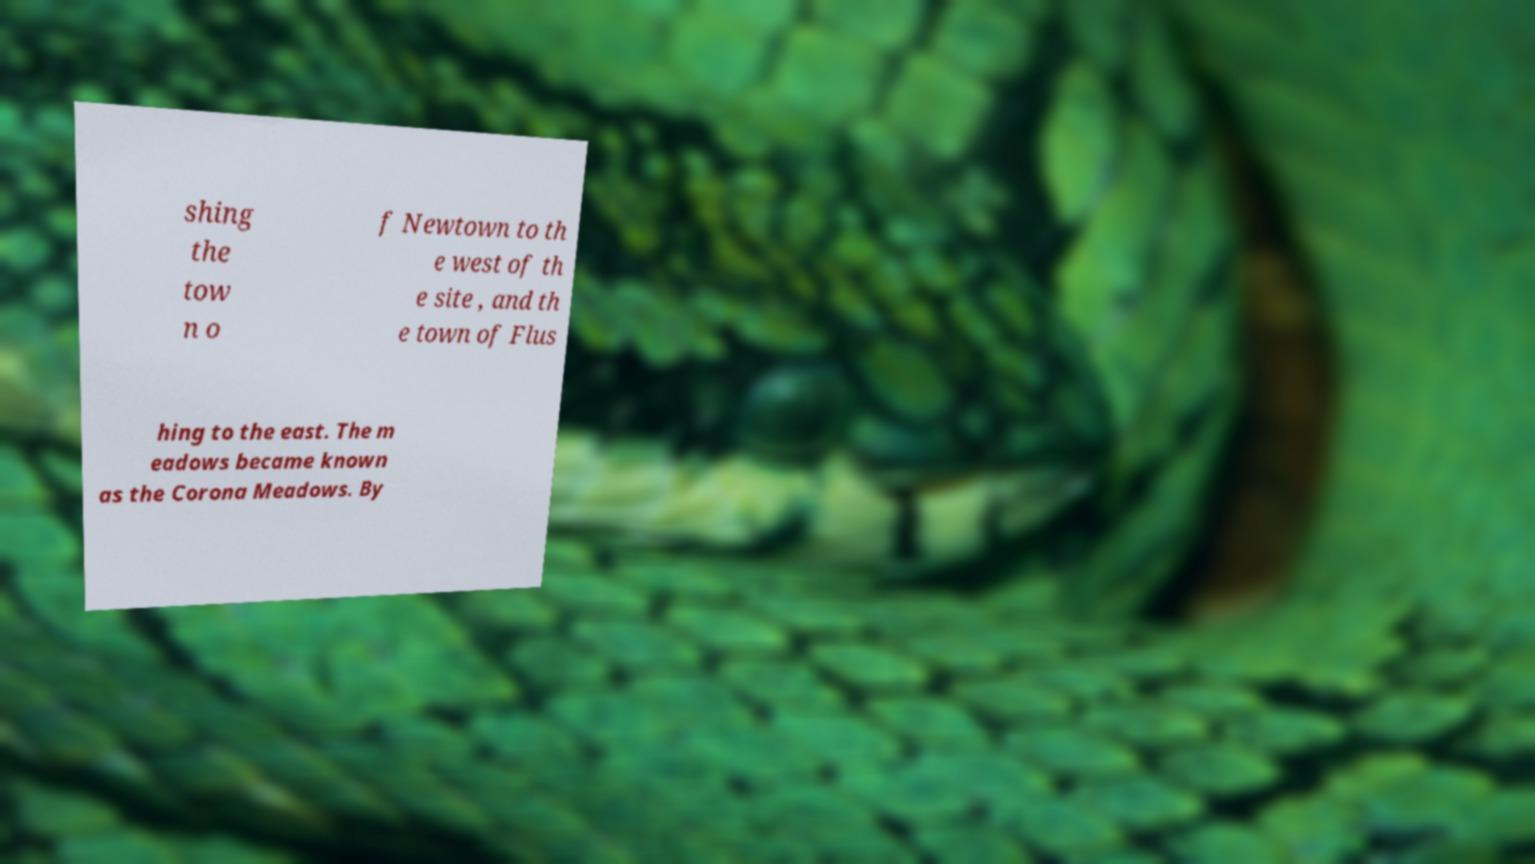I need the written content from this picture converted into text. Can you do that? shing the tow n o f Newtown to th e west of th e site , and th e town of Flus hing to the east. The m eadows became known as the Corona Meadows. By 